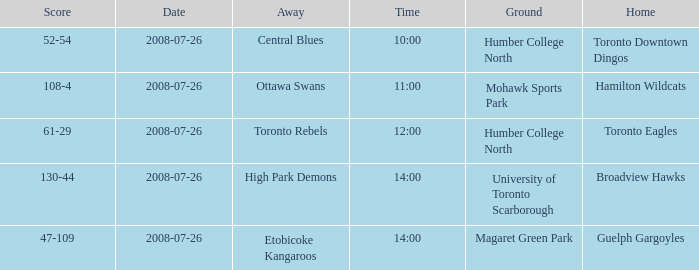Who has the Home Score of 52-54? Toronto Downtown Dingos. 